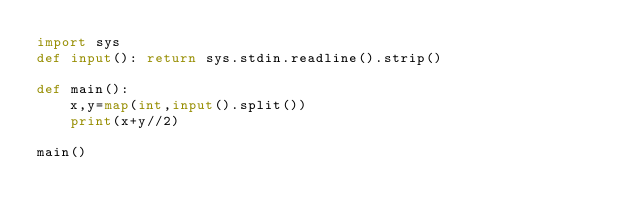Convert code to text. <code><loc_0><loc_0><loc_500><loc_500><_Python_>import sys
def input(): return sys.stdin.readline().strip()

def main():
    x,y=map(int,input().split())
    print(x+y//2)

main()</code> 